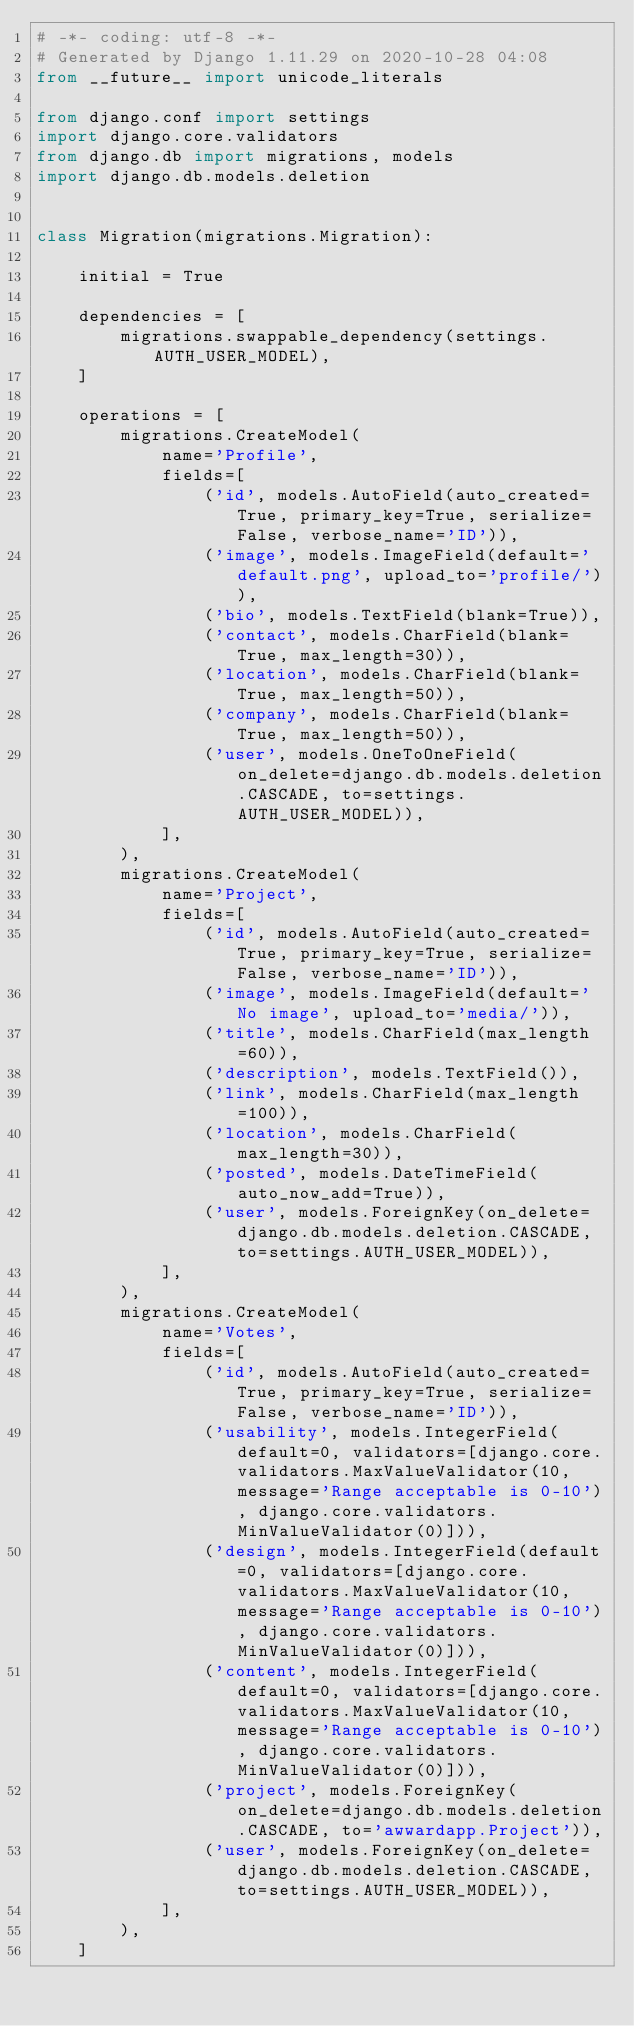<code> <loc_0><loc_0><loc_500><loc_500><_Python_># -*- coding: utf-8 -*-
# Generated by Django 1.11.29 on 2020-10-28 04:08
from __future__ import unicode_literals

from django.conf import settings
import django.core.validators
from django.db import migrations, models
import django.db.models.deletion


class Migration(migrations.Migration):

    initial = True

    dependencies = [
        migrations.swappable_dependency(settings.AUTH_USER_MODEL),
    ]

    operations = [
        migrations.CreateModel(
            name='Profile',
            fields=[
                ('id', models.AutoField(auto_created=True, primary_key=True, serialize=False, verbose_name='ID')),
                ('image', models.ImageField(default='default.png', upload_to='profile/')),
                ('bio', models.TextField(blank=True)),
                ('contact', models.CharField(blank=True, max_length=30)),
                ('location', models.CharField(blank=True, max_length=50)),
                ('company', models.CharField(blank=True, max_length=50)),
                ('user', models.OneToOneField(on_delete=django.db.models.deletion.CASCADE, to=settings.AUTH_USER_MODEL)),
            ],
        ),
        migrations.CreateModel(
            name='Project',
            fields=[
                ('id', models.AutoField(auto_created=True, primary_key=True, serialize=False, verbose_name='ID')),
                ('image', models.ImageField(default='No image', upload_to='media/')),
                ('title', models.CharField(max_length=60)),
                ('description', models.TextField()),
                ('link', models.CharField(max_length=100)),
                ('location', models.CharField(max_length=30)),
                ('posted', models.DateTimeField(auto_now_add=True)),
                ('user', models.ForeignKey(on_delete=django.db.models.deletion.CASCADE, to=settings.AUTH_USER_MODEL)),
            ],
        ),
        migrations.CreateModel(
            name='Votes',
            fields=[
                ('id', models.AutoField(auto_created=True, primary_key=True, serialize=False, verbose_name='ID')),
                ('usability', models.IntegerField(default=0, validators=[django.core.validators.MaxValueValidator(10, message='Range acceptable is 0-10'), django.core.validators.MinValueValidator(0)])),
                ('design', models.IntegerField(default=0, validators=[django.core.validators.MaxValueValidator(10, message='Range acceptable is 0-10'), django.core.validators.MinValueValidator(0)])),
                ('content', models.IntegerField(default=0, validators=[django.core.validators.MaxValueValidator(10, message='Range acceptable is 0-10'), django.core.validators.MinValueValidator(0)])),
                ('project', models.ForeignKey(on_delete=django.db.models.deletion.CASCADE, to='awwardapp.Project')),
                ('user', models.ForeignKey(on_delete=django.db.models.deletion.CASCADE, to=settings.AUTH_USER_MODEL)),
            ],
        ),
    ]
</code> 